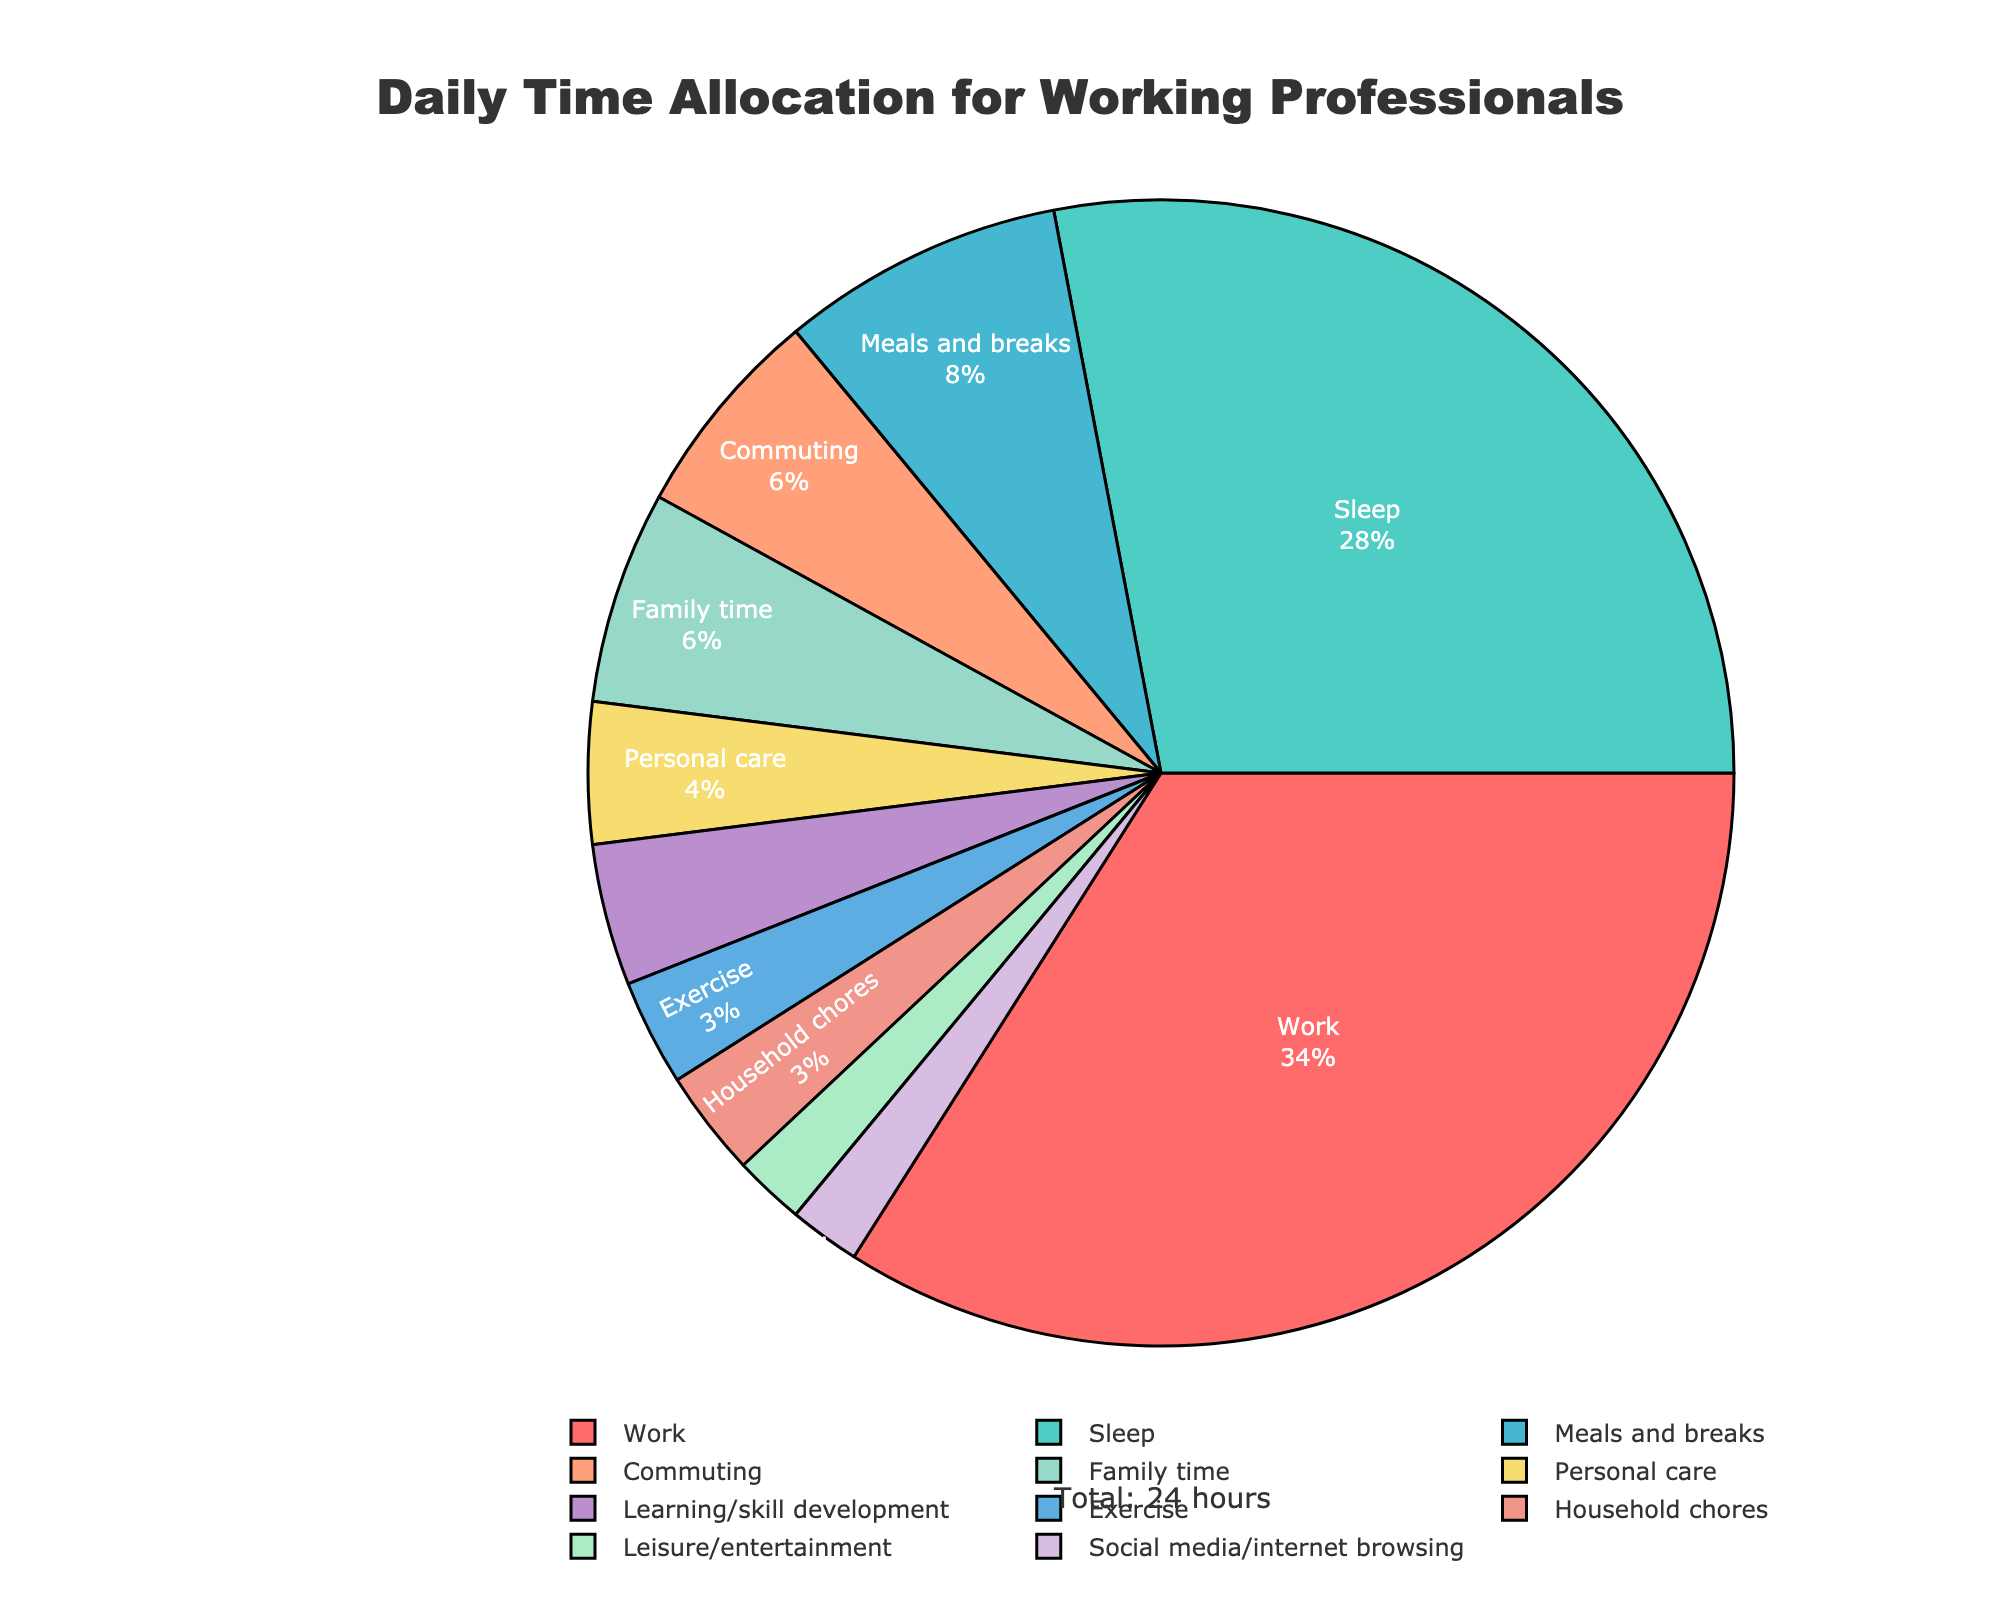What activity takes the largest portion of the pie chart? The largest portion of the pie chart is visually the area with the most significant segment, labeled as "Work."
Answer: Work What is the total percentage of time spent on Work and Sleep combined? The pie chart shows 8.5 hours for Work and 7 hours for Sleep. Adding these gives 8.5 + 7 = 15.5 hours. To find the percentage, (15.5/24)*100% = 64.58%.
Answer: 64.58% Which activities are allocated exactly or less than 1 hour? Referring to the pie chart, activities with segments representing less or equal to 1 hour include Exercise (0.75), Personal care (1), Learning/skill development (1), Leisure/entertainment (0.5), Household chores (0.75), and Social media/internet browsing (0.5).
Answer: Exercise, Personal care, Learning/skill development, Leisure/entertainment, Household chores, Social media/internet browsing How does the time spent on Commuting compare to the time spent on Family time? From the pie chart, Commuting is 1.5 hours, and Family time is also 1.5 hours. Thus, the time spent on both activities is equal.
Answer: Equal What activity has the smallest portion in the pie chart, and what is its percentage? The smallest portion in the pie chart visually represents the activity labeled "Leisure/entertainment," which consists of 0.5 hours. The percentage is (0.5/24)*100% = 2.08%.
Answer: Leisure/entertainment, 2.08% What is the combined time allocation for Exercise and Household chores? Exercise is allocated 0.75 hours, and Household chores are allocated 0.75 hours. Adding these together, 0.75 + 0.75 = 1.5 hours.
Answer: 1.5 hours Which activity is represented by green color in the pie chart? Examining the color matching, the green-colored segment represents "Sleep."
Answer: Sleep Is there any activity that has the same time allocation as Meals and breaks? Meals and breaks are allocated 2 hours. No other activity has been allocated exactly 2 hours according to the pie chart.
Answer: None What is the percentage of time spent on Personal care, and how is it visually represented? The pie chart shows that Personal care is allocated 1 hour. The percentage is (1/24)*100% = 4.17%. Visually, this segment is represented in a light pink color.
Answer: 4.17%, light pink How much more time is allocated to Work compared to Exercise? Work is allocated 8.5 hours, and Exercise is 0.75 hours. The difference is 8.5 - 0.75 = 7.75 hours.
Answer: 7.75 hours 